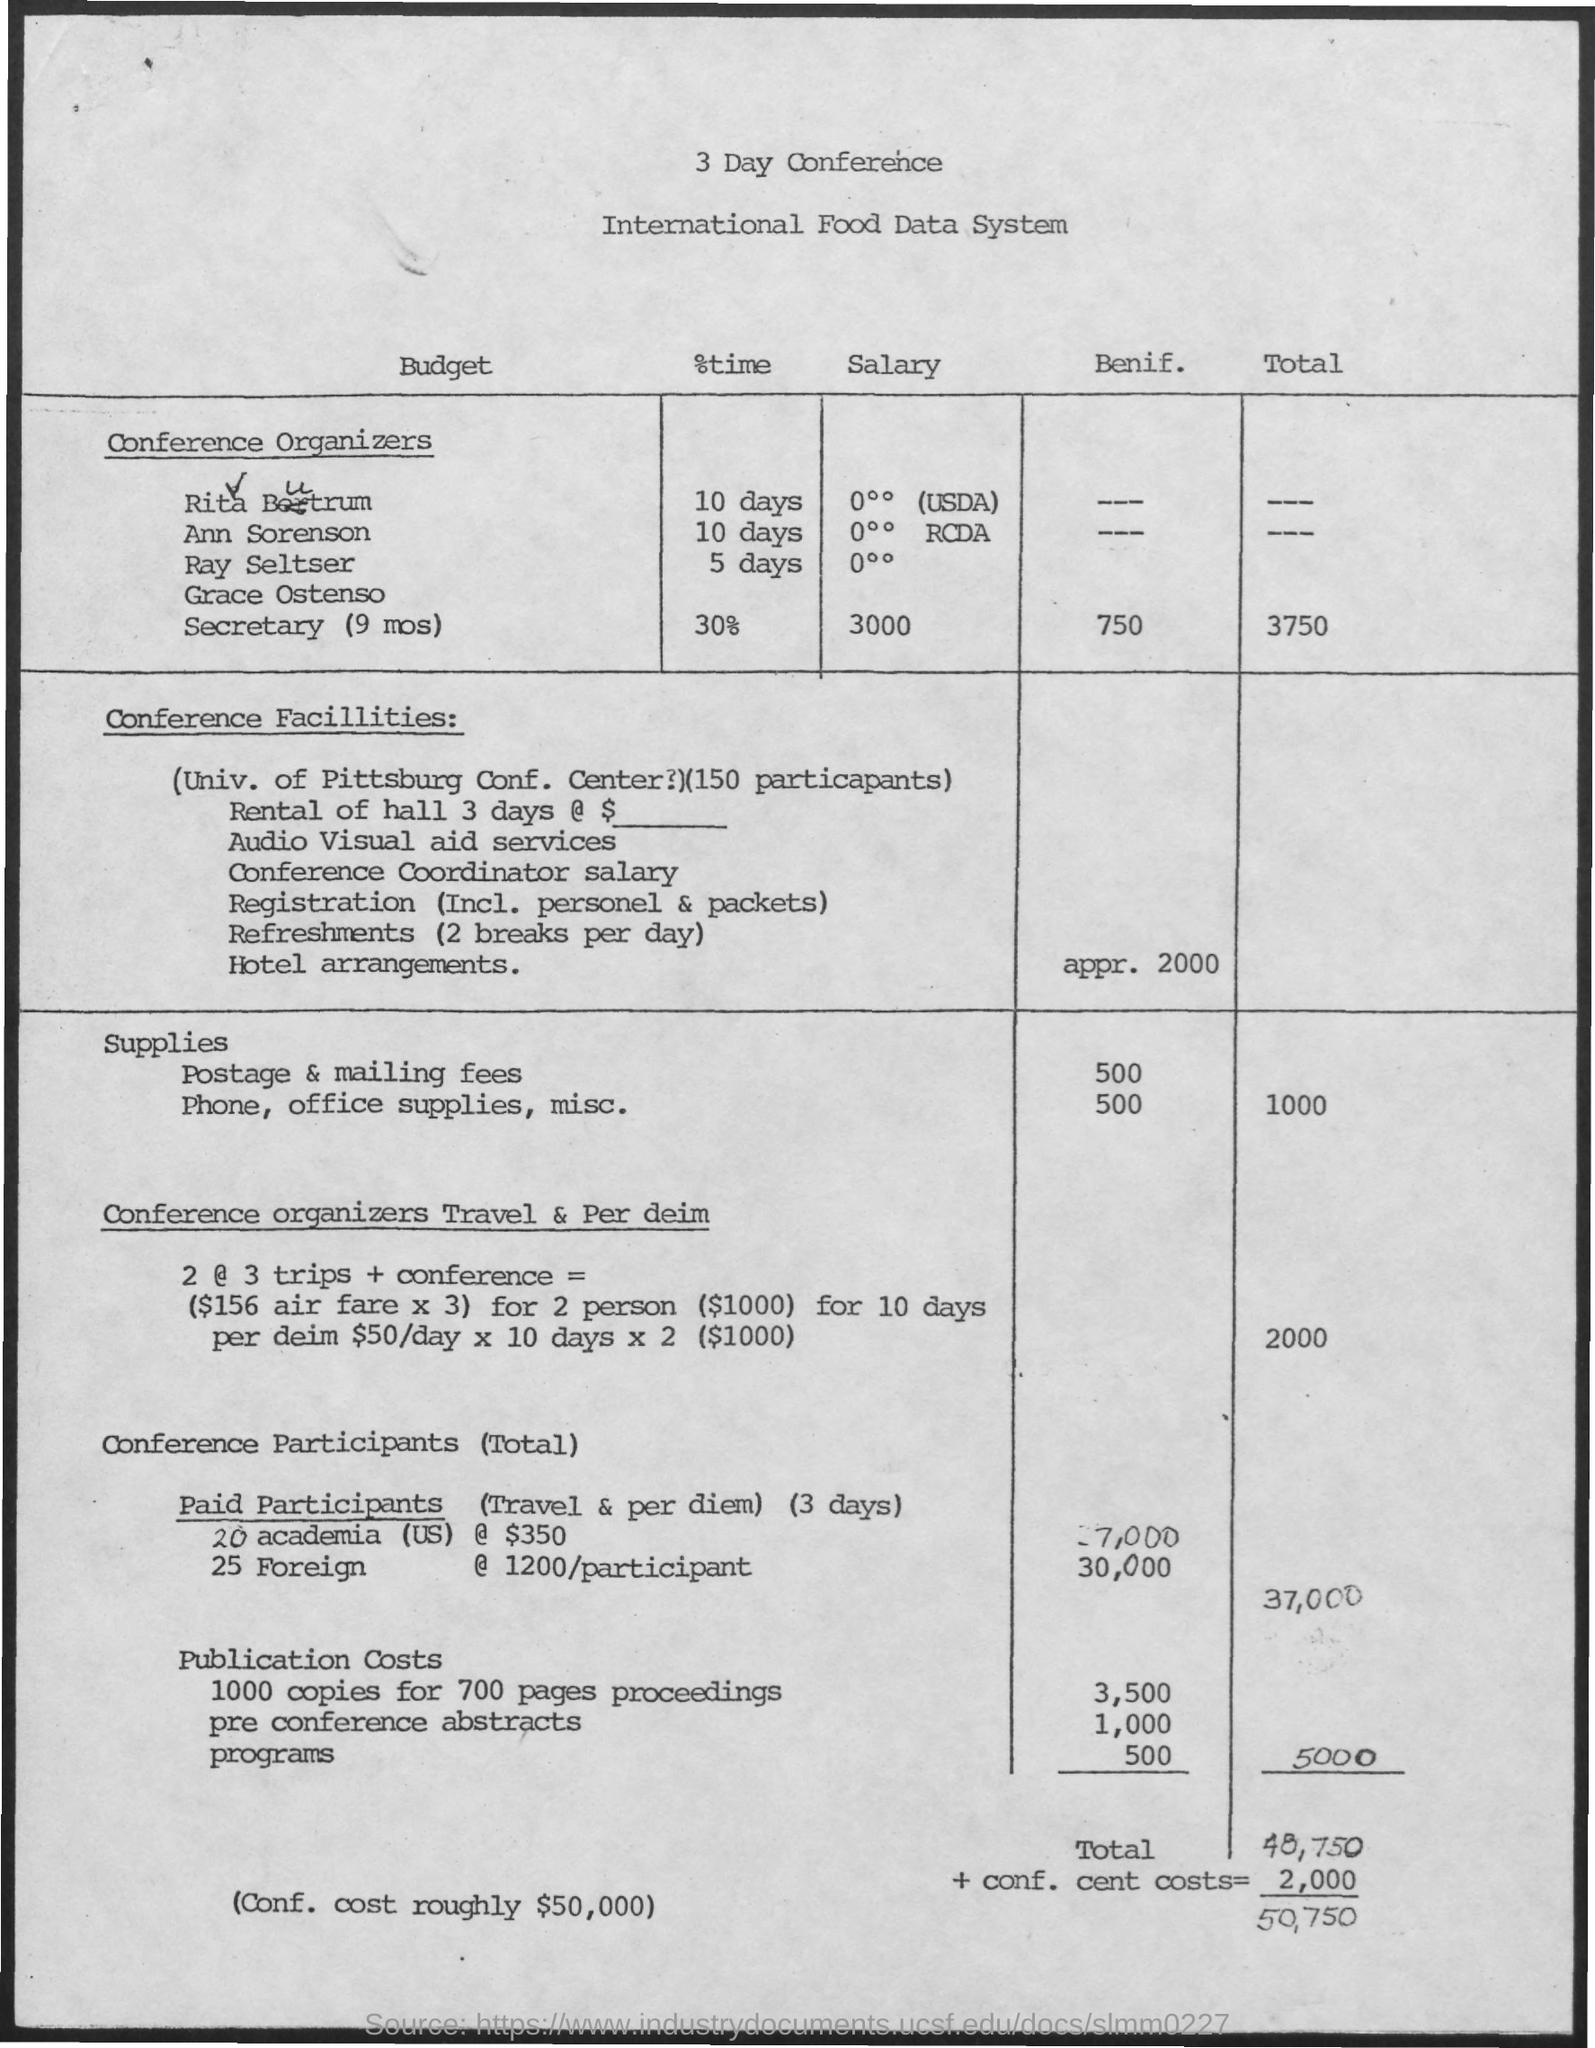List a handful of essential elements in this visual. The conference will last for 3 days. 